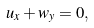<formula> <loc_0><loc_0><loc_500><loc_500>u _ { x } + w _ { y } = 0 ,</formula> 